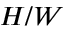Convert formula to latex. <formula><loc_0><loc_0><loc_500><loc_500>H / W</formula> 